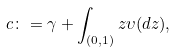<formula> <loc_0><loc_0><loc_500><loc_500>c \colon = \gamma + \int _ { ( 0 , 1 ) } z \upsilon ( d z ) ,</formula> 